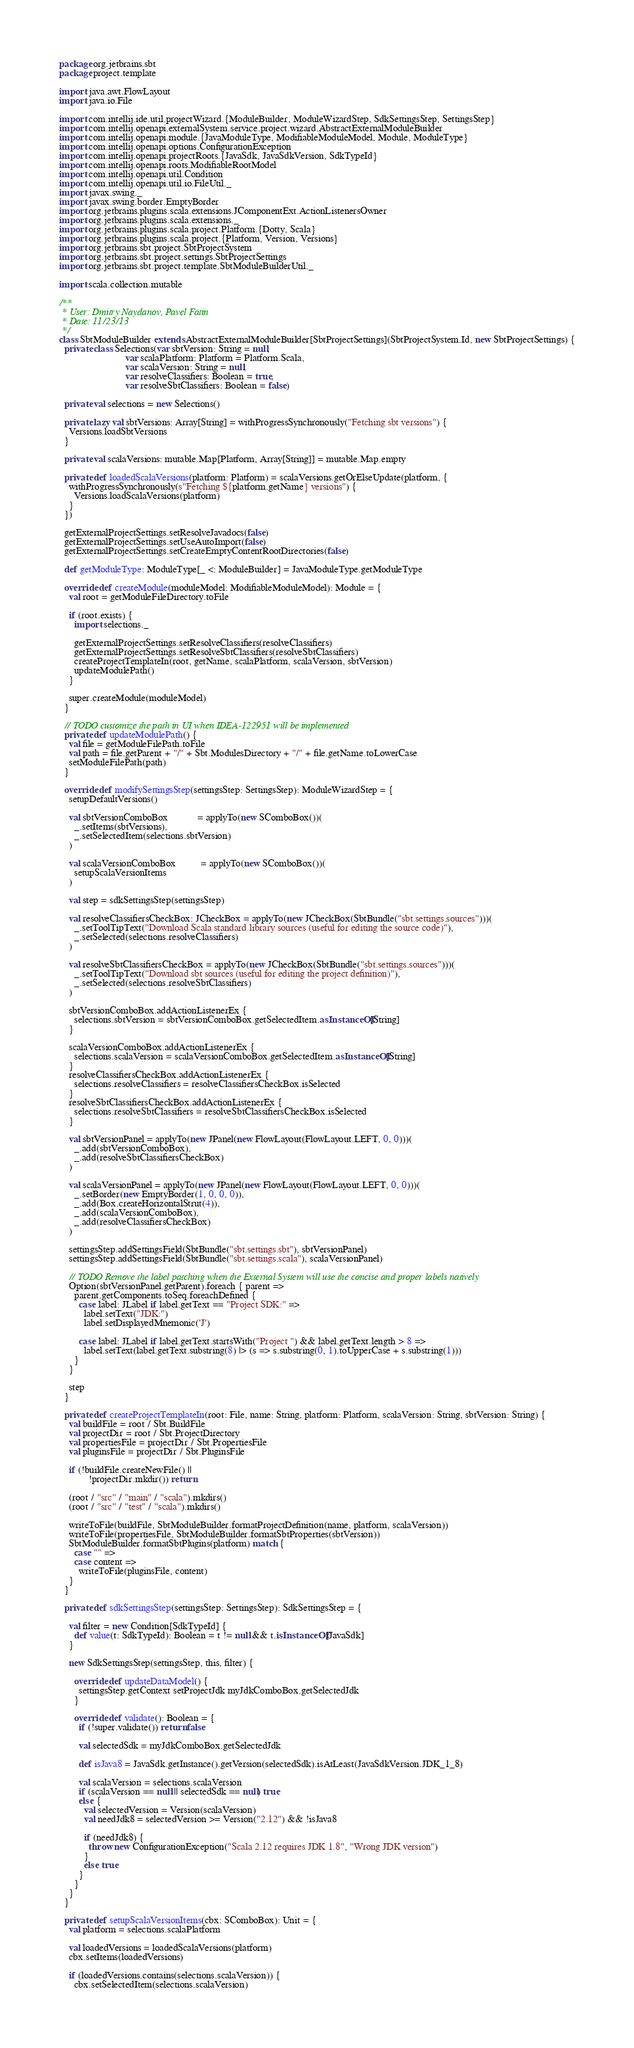<code> <loc_0><loc_0><loc_500><loc_500><_Scala_>package org.jetbrains.sbt
package project.template

import java.awt.FlowLayout
import java.io.File

import com.intellij.ide.util.projectWizard.{ModuleBuilder, ModuleWizardStep, SdkSettingsStep, SettingsStep}
import com.intellij.openapi.externalSystem.service.project.wizard.AbstractExternalModuleBuilder
import com.intellij.openapi.module.{JavaModuleType, ModifiableModuleModel, Module, ModuleType}
import com.intellij.openapi.options.ConfigurationException
import com.intellij.openapi.projectRoots.{JavaSdk, JavaSdkVersion, SdkTypeId}
import com.intellij.openapi.roots.ModifiableRootModel
import com.intellij.openapi.util.Condition
import com.intellij.openapi.util.io.FileUtil._
import javax.swing._
import javax.swing.border.EmptyBorder
import org.jetbrains.plugins.scala.extensions.JComponentExt.ActionListenersOwner
import org.jetbrains.plugins.scala.extensions._
import org.jetbrains.plugins.scala.project.Platform.{Dotty, Scala}
import org.jetbrains.plugins.scala.project.{Platform, Version, Versions}
import org.jetbrains.sbt.project.SbtProjectSystem
import org.jetbrains.sbt.project.settings.SbtProjectSettings
import org.jetbrains.sbt.project.template.SbtModuleBuilderUtil._

import scala.collection.mutable

/**
 * User: Dmitry Naydanov, Pavel Fatin
 * Date: 11/23/13
 */
class SbtModuleBuilder extends AbstractExternalModuleBuilder[SbtProjectSettings](SbtProjectSystem.Id, new SbtProjectSettings) {
  private class Selections(var sbtVersion: String = null,
                           var scalaPlatform: Platform = Platform.Scala,
                           var scalaVersion: String = null,
                           var resolveClassifiers: Boolean = true,
                           var resolveSbtClassifiers: Boolean = false)

  private val selections = new Selections()

  private lazy val sbtVersions: Array[String] = withProgressSynchronously("Fetching sbt versions") {
    Versions.loadSbtVersions
  }

  private val scalaVersions: mutable.Map[Platform, Array[String]] = mutable.Map.empty

  private def loadedScalaVersions(platform: Platform) = scalaVersions.getOrElseUpdate(platform, {
    withProgressSynchronously(s"Fetching ${platform.getName} versions") {
      Versions.loadScalaVersions(platform)
    }
  })

  getExternalProjectSettings.setResolveJavadocs(false)
  getExternalProjectSettings.setUseAutoImport(false)
  getExternalProjectSettings.setCreateEmptyContentRootDirectories(false)

  def getModuleType: ModuleType[_ <: ModuleBuilder] = JavaModuleType.getModuleType

  override def createModule(moduleModel: ModifiableModuleModel): Module = {
    val root = getModuleFileDirectory.toFile

    if (root.exists) {
      import selections._

      getExternalProjectSettings.setResolveClassifiers(resolveClassifiers)
      getExternalProjectSettings.setResolveSbtClassifiers(resolveSbtClassifiers)
      createProjectTemplateIn(root, getName, scalaPlatform, scalaVersion, sbtVersion)
      updateModulePath()
    }

    super.createModule(moduleModel)
  }

  // TODO customize the path in UI when IDEA-122951 will be implemented
  private def updateModulePath() {
    val file = getModuleFilePath.toFile
    val path = file.getParent + "/" + Sbt.ModulesDirectory + "/" + file.getName.toLowerCase
    setModuleFilePath(path)
  }

  override def modifySettingsStep(settingsStep: SettingsStep): ModuleWizardStep = {
    setupDefaultVersions()

    val sbtVersionComboBox            = applyTo(new SComboBox())(
      _.setItems(sbtVersions),
      _.setSelectedItem(selections.sbtVersion)
    )

    val scalaVersionComboBox          = applyTo(new SComboBox())(
      setupScalaVersionItems
    )

    val step = sdkSettingsStep(settingsStep)

    val resolveClassifiersCheckBox: JCheckBox = applyTo(new JCheckBox(SbtBundle("sbt.settings.sources")))(
      _.setToolTipText("Download Scala standard library sources (useful for editing the source code)"),
      _.setSelected(selections.resolveClassifiers)
    )

    val resolveSbtClassifiersCheckBox = applyTo(new JCheckBox(SbtBundle("sbt.settings.sources")))(
      _.setToolTipText("Download sbt sources (useful for editing the project definition)"),
      _.setSelected(selections.resolveSbtClassifiers)
    )

    sbtVersionComboBox.addActionListenerEx {
      selections.sbtVersion = sbtVersionComboBox.getSelectedItem.asInstanceOf[String]
    }

    scalaVersionComboBox.addActionListenerEx {
      selections.scalaVersion = scalaVersionComboBox.getSelectedItem.asInstanceOf[String]
    }
    resolveClassifiersCheckBox.addActionListenerEx {
      selections.resolveClassifiers = resolveClassifiersCheckBox.isSelected
    }
    resolveSbtClassifiersCheckBox.addActionListenerEx {
      selections.resolveSbtClassifiers = resolveSbtClassifiersCheckBox.isSelected
    }

    val sbtVersionPanel = applyTo(new JPanel(new FlowLayout(FlowLayout.LEFT, 0, 0)))(
      _.add(sbtVersionComboBox),
      _.add(resolveSbtClassifiersCheckBox)
    )

    val scalaVersionPanel = applyTo(new JPanel(new FlowLayout(FlowLayout.LEFT, 0, 0)))(
      _.setBorder(new EmptyBorder(1, 0, 0, 0)),
      _.add(Box.createHorizontalStrut(4)),
      _.add(scalaVersionComboBox),
      _.add(resolveClassifiersCheckBox)
    )

    settingsStep.addSettingsField(SbtBundle("sbt.settings.sbt"), sbtVersionPanel)
    settingsStep.addSettingsField(SbtBundle("sbt.settings.scala"), scalaVersionPanel)

    // TODO Remove the label patching when the External System will use the concise and proper labels natively
    Option(sbtVersionPanel.getParent).foreach { parent =>
      parent.getComponents.toSeq.foreachDefined {
        case label: JLabel if label.getText == "Project SDK:" =>
          label.setText("JDK:")
          label.setDisplayedMnemonic('J')

        case label: JLabel if label.getText.startsWith("Project ") && label.getText.length > 8 =>
          label.setText(label.getText.substring(8) |> (s => s.substring(0, 1).toUpperCase + s.substring(1)))
      }
    }

    step
  }

  private def createProjectTemplateIn(root: File, name: String, platform: Platform, scalaVersion: String, sbtVersion: String) {
    val buildFile = root / Sbt.BuildFile
    val projectDir = root / Sbt.ProjectDirectory
    val propertiesFile = projectDir / Sbt.PropertiesFile
    val pluginsFile = projectDir / Sbt.PluginsFile

    if (!buildFile.createNewFile() ||
            !projectDir.mkdir()) return

    (root / "src" / "main" / "scala").mkdirs()
    (root / "src" / "test" / "scala").mkdirs()

    writeToFile(buildFile, SbtModuleBuilder.formatProjectDefinition(name, platform, scalaVersion))
    writeToFile(propertiesFile, SbtModuleBuilder.formatSbtProperties(sbtVersion))
    SbtModuleBuilder.formatSbtPlugins(platform) match {
      case "" =>
      case content =>
        writeToFile(pluginsFile, content)
    }
  }

  private def sdkSettingsStep(settingsStep: SettingsStep): SdkSettingsStep = {

    val filter = new Condition[SdkTypeId] {
      def value(t: SdkTypeId): Boolean = t != null && t.isInstanceOf[JavaSdk]
    }

    new SdkSettingsStep(settingsStep, this, filter) {

      override def updateDataModel() {
        settingsStep.getContext setProjectJdk myJdkComboBox.getSelectedJdk
      }

      override def validate(): Boolean = {
        if (!super.validate()) return false

        val selectedSdk = myJdkComboBox.getSelectedJdk

        def isJava8 = JavaSdk.getInstance().getVersion(selectedSdk).isAtLeast(JavaSdkVersion.JDK_1_8)

        val scalaVersion = selections.scalaVersion
        if (scalaVersion == null || selectedSdk == null) true
        else {
          val selectedVersion = Version(scalaVersion)
          val needJdk8 = selectedVersion >= Version("2.12") && !isJava8

          if (needJdk8) {
            throw new ConfigurationException("Scala 2.12 requires JDK 1.8", "Wrong JDK version")
          }
          else true
        }
      }
    }
  }

  private def setupScalaVersionItems(cbx: SComboBox): Unit = {
    val platform = selections.scalaPlatform

    val loadedVersions = loadedScalaVersions(platform)
    cbx.setItems(loadedVersions)

    if (loadedVersions.contains(selections.scalaVersion)) {
      cbx.setSelectedItem(selections.scalaVersion)</code> 